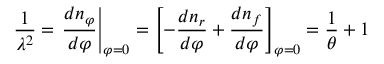<formula> <loc_0><loc_0><loc_500><loc_500>{ \frac { 1 } { \lambda ^ { 2 } } } = { \frac { d n _ { \varphi } } { d \varphi } } \right | _ { \varphi = 0 } = \left [ - { \frac { d n _ { r } } { d \varphi } } + { \frac { d n _ { f } } { d \varphi } } \right ] _ { \varphi = 0 } = { \frac { 1 } { \theta } } + 1</formula> 